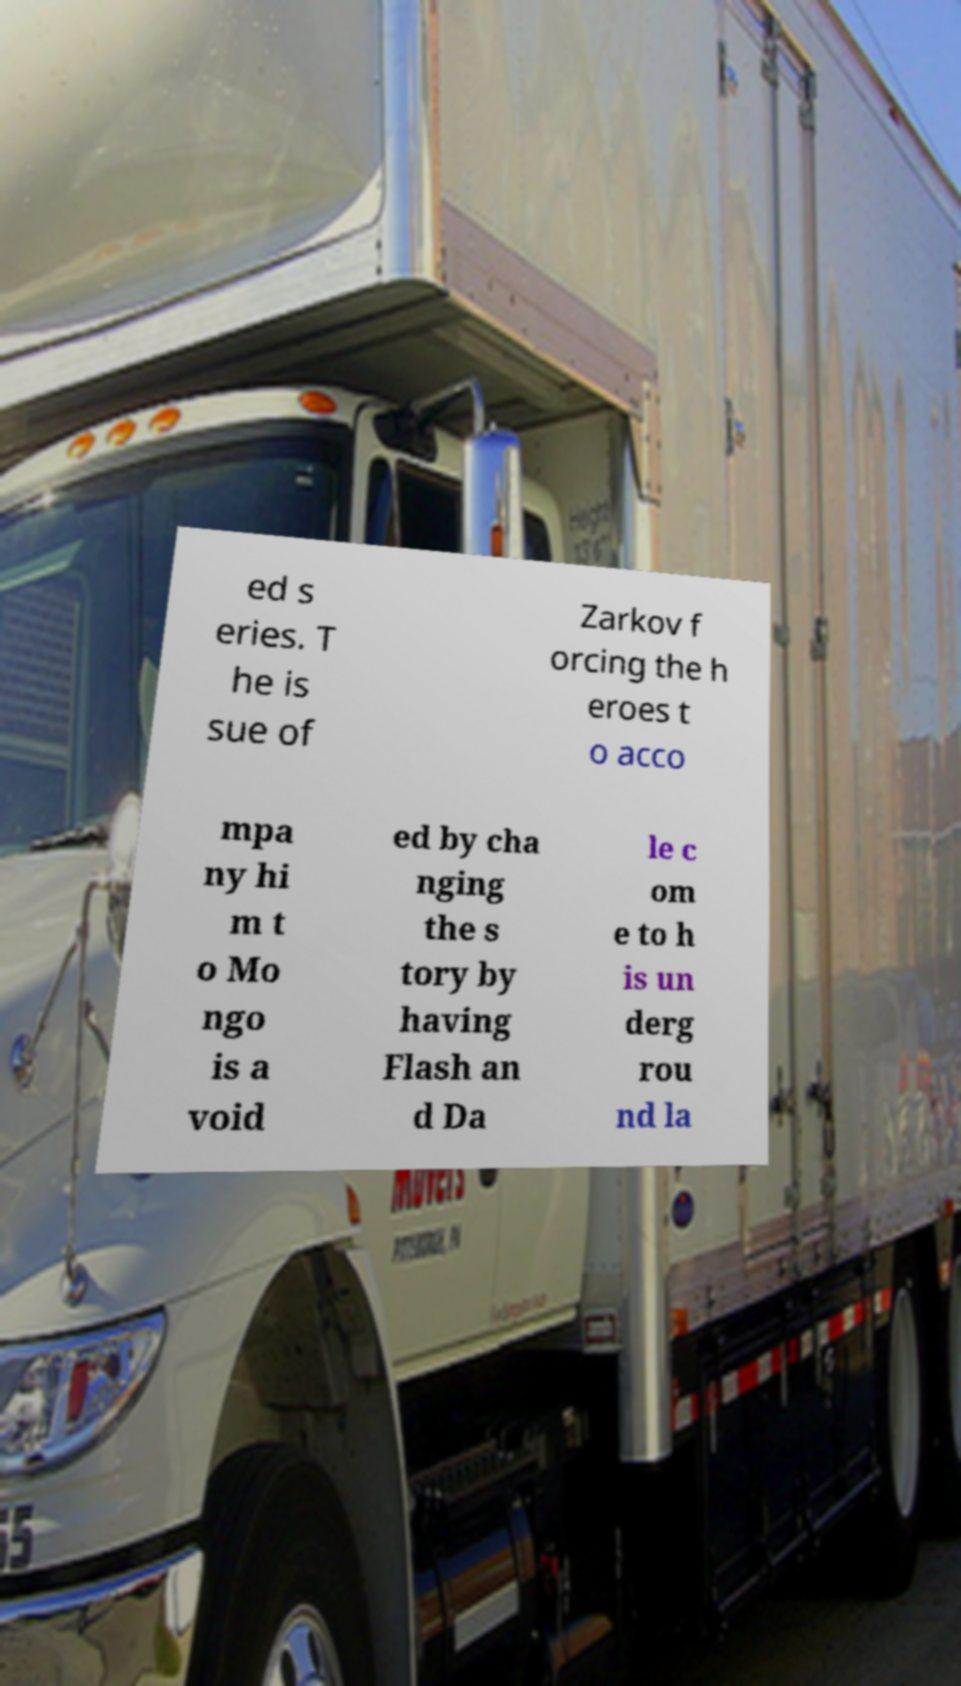For documentation purposes, I need the text within this image transcribed. Could you provide that? ed s eries. T he is sue of Zarkov f orcing the h eroes t o acco mpa ny hi m t o Mo ngo is a void ed by cha nging the s tory by having Flash an d Da le c om e to h is un derg rou nd la 